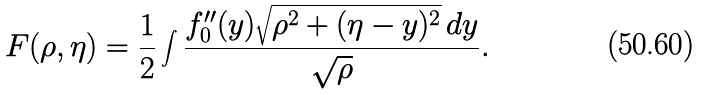<formula> <loc_0><loc_0><loc_500><loc_500>F ( \rho , \eta ) = \frac { 1 } { 2 } \int \frac { f _ { 0 } ^ { \prime \prime } ( y ) \sqrt { \rho ^ { 2 } + ( \eta - y ) ^ { 2 } } \, d y } { \sqrt { \rho } } .</formula> 